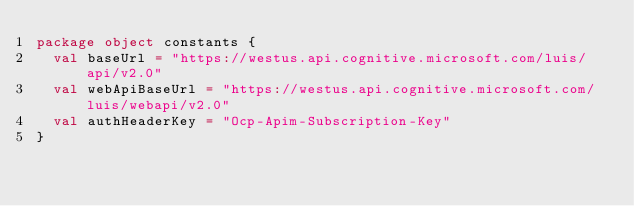Convert code to text. <code><loc_0><loc_0><loc_500><loc_500><_Scala_>package object constants {
  val baseUrl = "https://westus.api.cognitive.microsoft.com/luis/api/v2.0"
  val webApiBaseUrl = "https://westus.api.cognitive.microsoft.com/luis/webapi/v2.0"
  val authHeaderKey = "Ocp-Apim-Subscription-Key"
}
</code> 